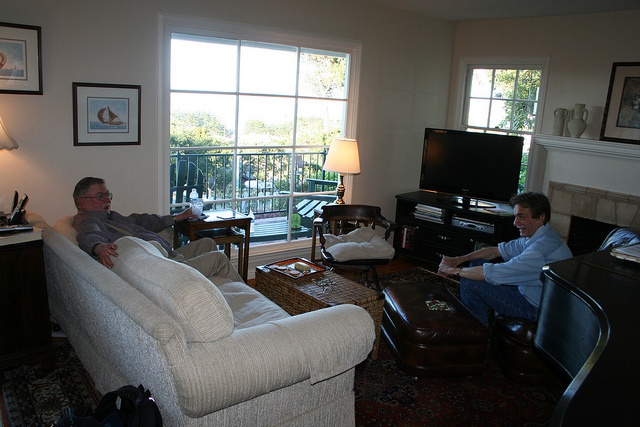Describe the objects in this image and their specific colors. I can see couch in black and gray tones, couch in black, darkgray, and gray tones, people in black, blue, gray, and darkblue tones, tv in black, blue, gray, and maroon tones, and people in black, gray, and maroon tones in this image. 